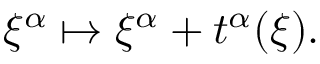Convert formula to latex. <formula><loc_0><loc_0><loc_500><loc_500>\xi ^ { \alpha } \mapsto \xi ^ { \alpha } + t ^ { \alpha } ( \xi ) .</formula> 